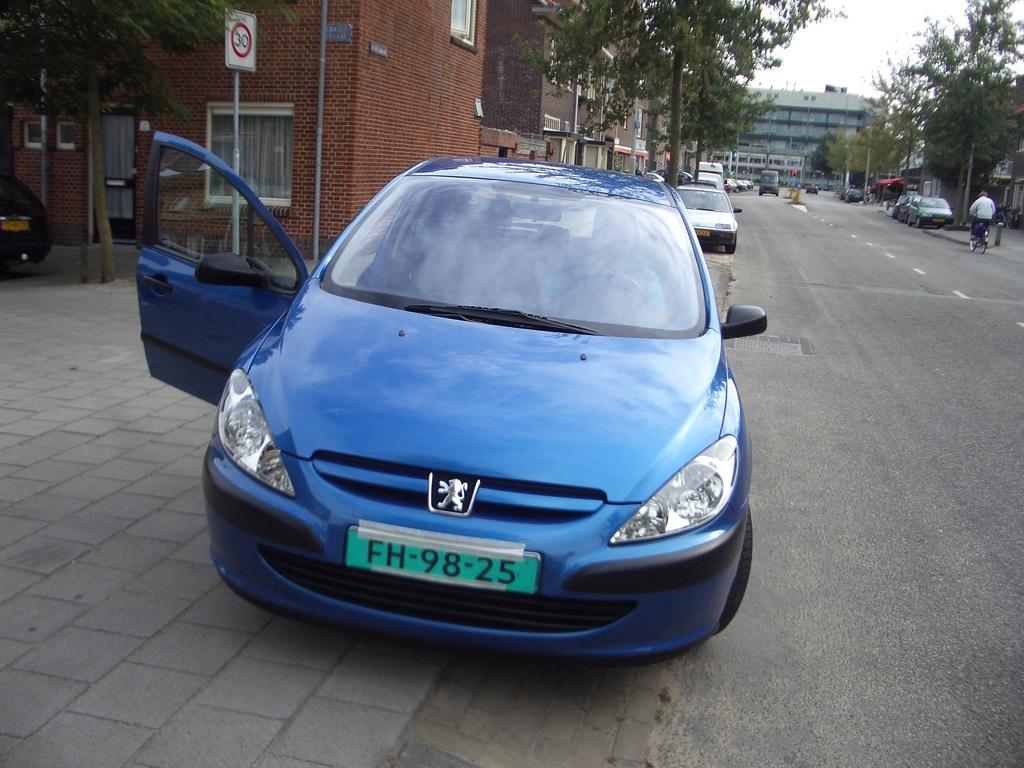What does the license plate say?
Keep it short and to the point. Fh-98-25. 